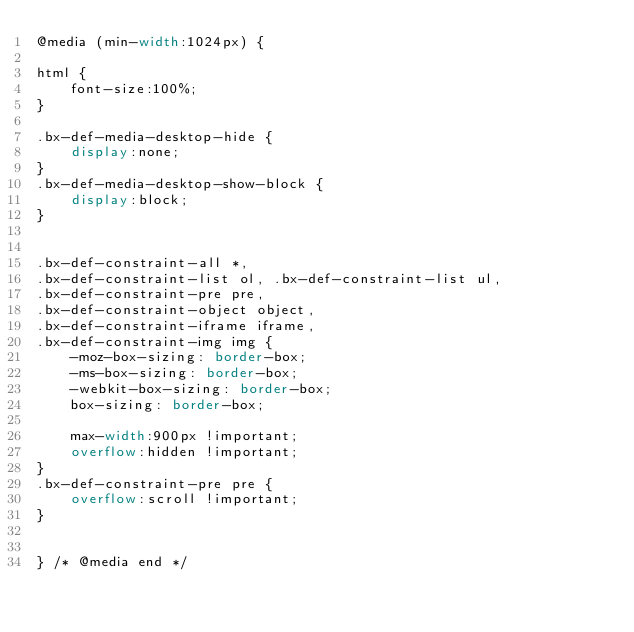<code> <loc_0><loc_0><loc_500><loc_500><_CSS_>@media (min-width:1024px) {

html {
    font-size:100%;
}

.bx-def-media-desktop-hide {
    display:none;
}
.bx-def-media-desktop-show-block {
    display:block;
}


.bx-def-constraint-all *,
.bx-def-constraint-list ol, .bx-def-constraint-list ul,
.bx-def-constraint-pre pre,
.bx-def-constraint-object object,
.bx-def-constraint-iframe iframe,
.bx-def-constraint-img img {
    -moz-box-sizing: border-box;
    -ms-box-sizing: border-box;
    -webkit-box-sizing: border-box;
    box-sizing: border-box;

    max-width:900px !important;
    overflow:hidden !important;
}
.bx-def-constraint-pre pre {
    overflow:scroll !important;
}


} /* @media end */
</code> 